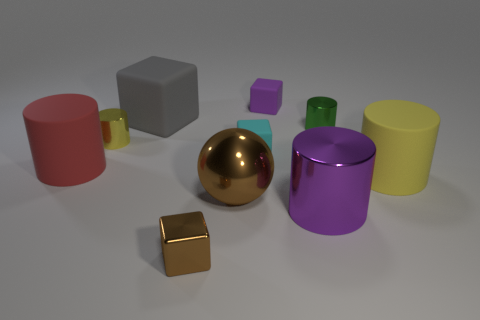What is the size of the metallic object that is the same color as the metallic sphere?
Provide a succinct answer. Small. What is the shape of the shiny object that is the same color as the big sphere?
Give a very brief answer. Cube. How many objects are blue matte blocks or small shiny things?
Your answer should be very brief. 3. What is the color of the large matte cylinder that is left of the purple object on the left side of the metallic cylinder in front of the red rubber cylinder?
Ensure brevity in your answer.  Red. Is there any other thing of the same color as the large block?
Provide a succinct answer. No. Do the gray matte thing and the metallic block have the same size?
Your answer should be compact. No. What number of objects are either things right of the big gray matte thing or cubes behind the tiny green cylinder?
Your answer should be compact. 8. What is the material of the yellow object that is on the right side of the cube in front of the red matte cylinder?
Your answer should be very brief. Rubber. What number of other objects are the same material as the large purple cylinder?
Offer a very short reply. 4. Do the purple metal object and the gray rubber thing have the same shape?
Keep it short and to the point. No. 